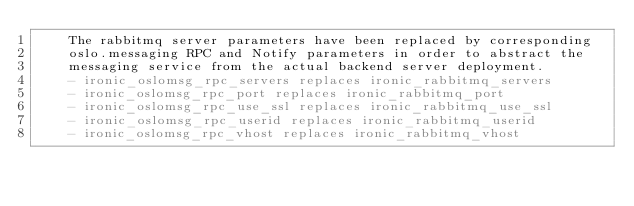<code> <loc_0><loc_0><loc_500><loc_500><_YAML_>    The rabbitmq server parameters have been replaced by corresponding
    oslo.messaging RPC and Notify parameters in order to abstract the
    messaging service from the actual backend server deployment.
    - ironic_oslomsg_rpc_servers replaces ironic_rabbitmq_servers
    - ironic_oslomsg_rpc_port replaces ironic_rabbitmq_port
    - ironic_oslomsg_rpc_use_ssl replaces ironic_rabbitmq_use_ssl
    - ironic_oslomsg_rpc_userid replaces ironic_rabbitmq_userid
    - ironic_oslomsg_rpc_vhost replaces ironic_rabbitmq_vhost
</code> 